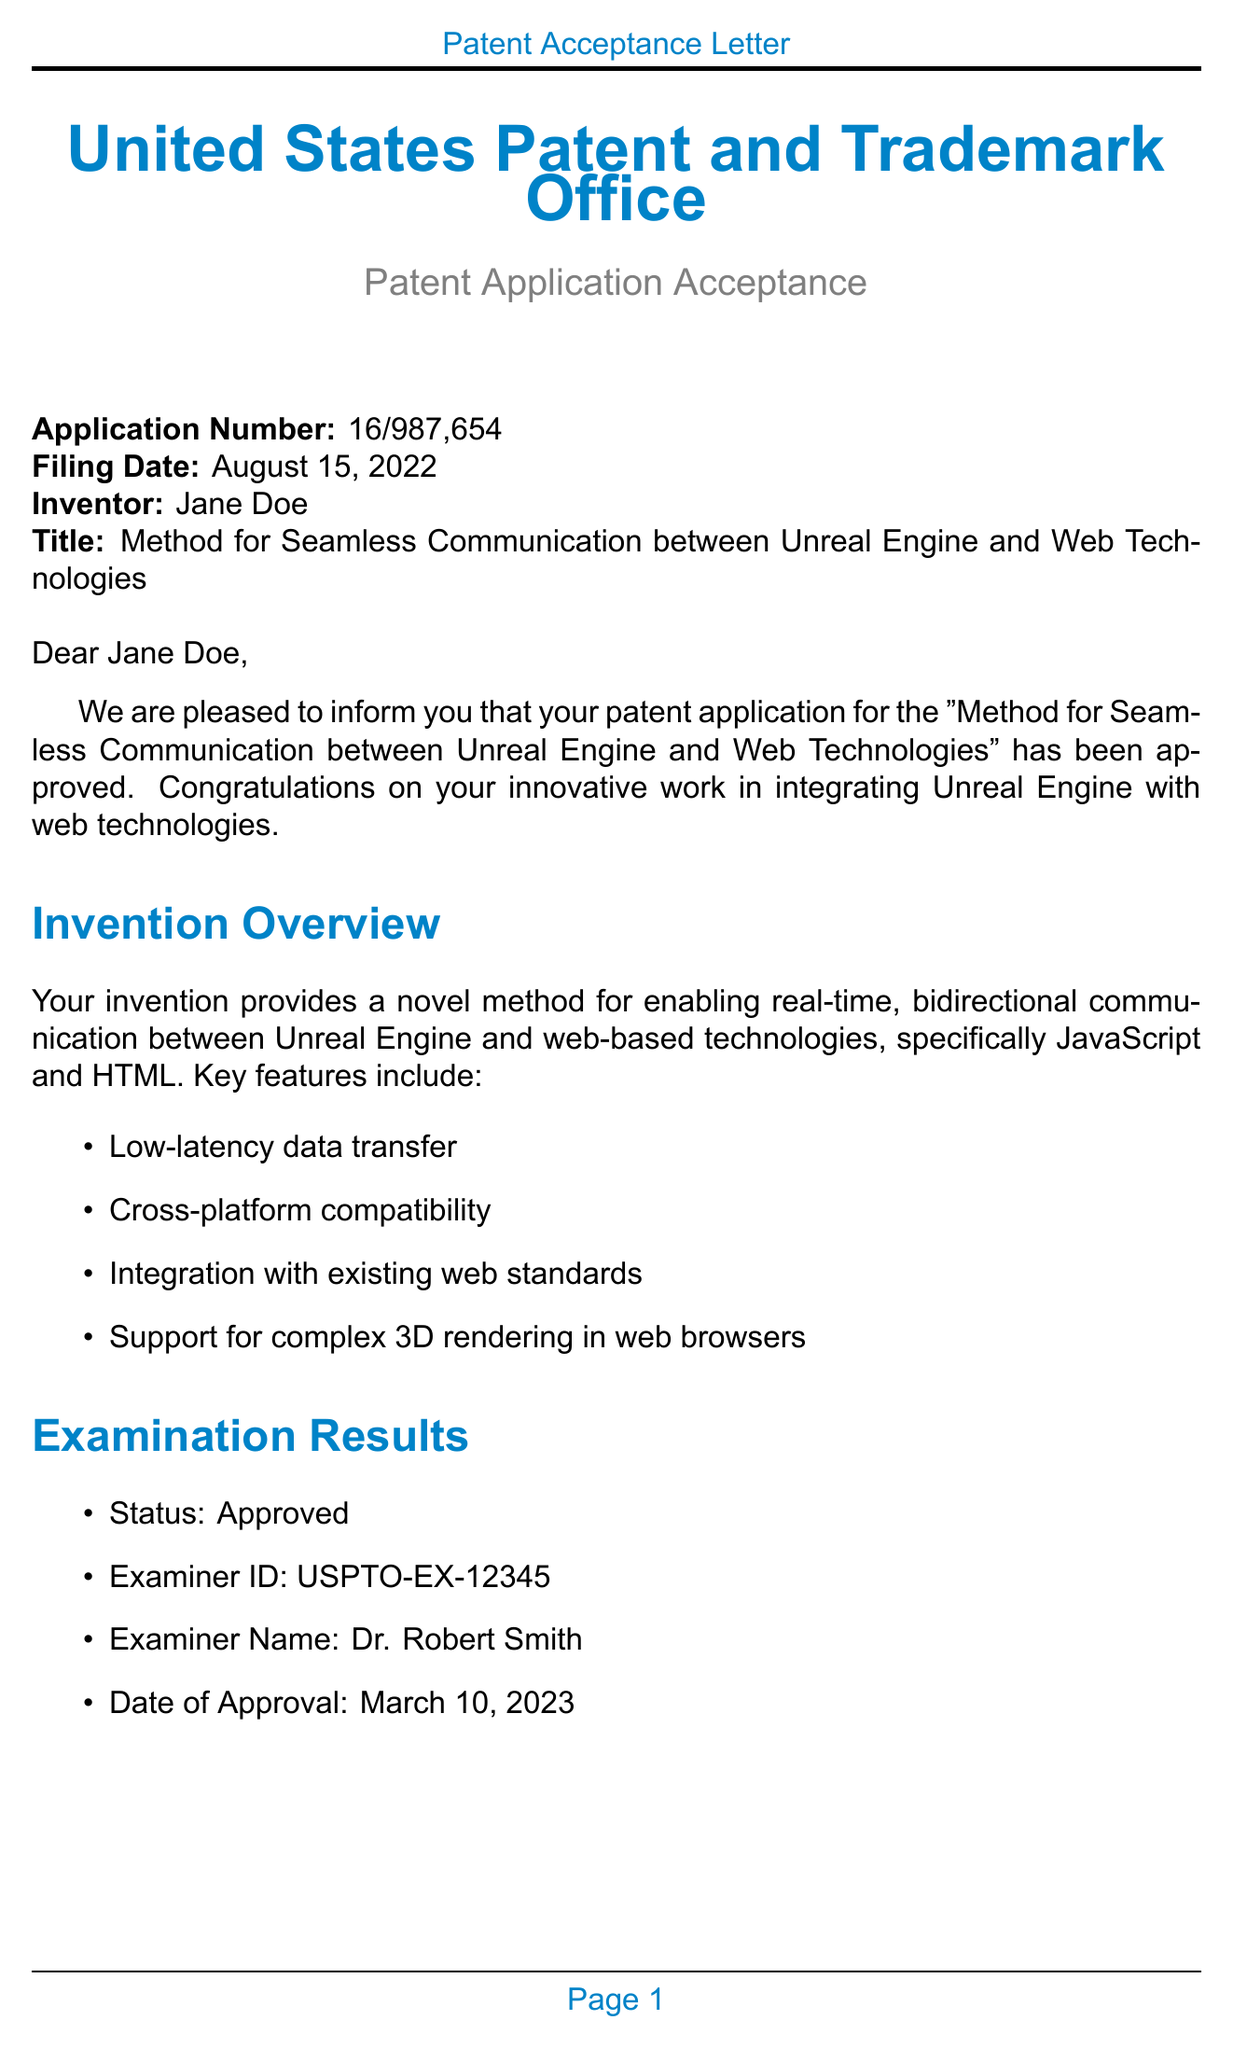What is the application number? The application number is explicitly stated in the header of the document.
Answer: 16/987,654 When was the filing date? The filing date is presented in the header section of the document.
Answer: August 15, 2022 Who is the inventor? The inventor's name is provided in the document's header section.
Answer: Jane Doe What is the status of the patent application? The status is noted in the examination results section of the letter.
Answer: Approved What is the issue fee amount? The amount of the issue fee is specified in the next steps section.
Answer: $1,200 What is the enforcement period for the patent? The enforcement period is listed under the legal information section of the letter.
Answer: 20 years from filing date Which programming languages are used in the invention? The programming languages are detailed in the technical details section.
Answer: C++, JavaScript, HTML5 What technologies are mentioned for web integration? This information is found in the technical details section of the letter.
Answer: WebGL 2.0, WebAssembly, WebSockets What are potential applications of the invention? Potential applications are outlined in the market relevance section of the letter.
Answer: Browser-based gaming, Interactive product configurators, Virtual training simulations, Web-based architectural visualization 